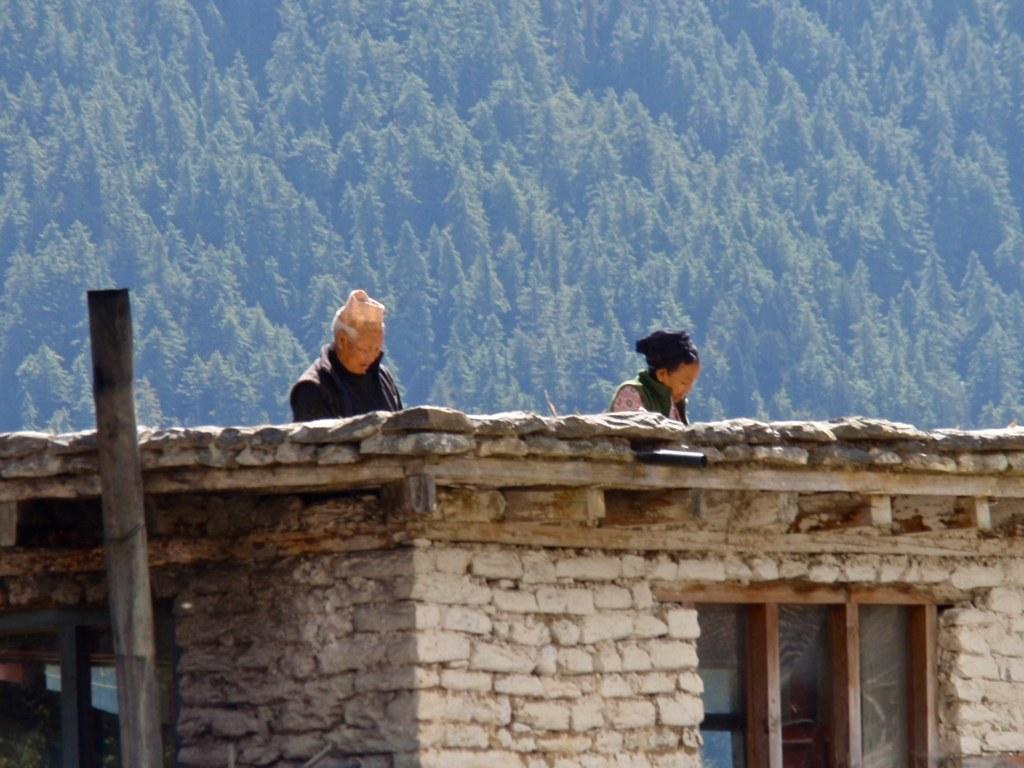Could you give a brief overview of what you see in this image? In this image we can see a brick house and a window. On the top one man and woman is there. Background of the image trees are present. 